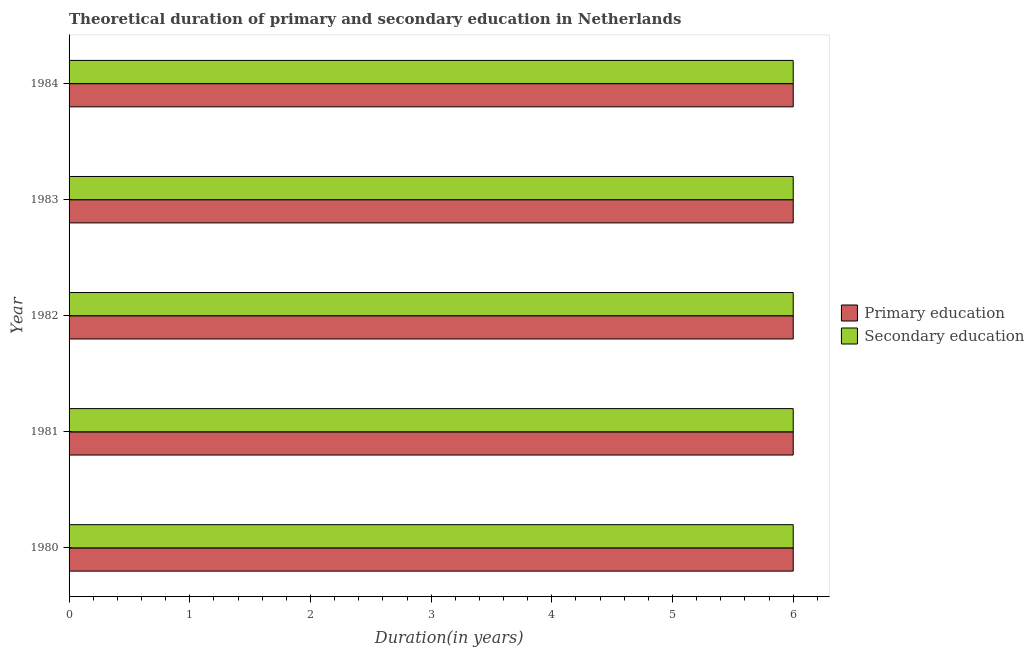Are the number of bars on each tick of the Y-axis equal?
Your answer should be compact. Yes. How many bars are there on the 2nd tick from the top?
Make the answer very short. 2. How many bars are there on the 4th tick from the bottom?
Make the answer very short. 2. What is the label of the 5th group of bars from the top?
Give a very brief answer. 1980. In how many cases, is the number of bars for a given year not equal to the number of legend labels?
Make the answer very short. 0. What is the duration of primary education in 1983?
Your answer should be very brief. 6. In which year was the duration of secondary education minimum?
Make the answer very short. 1980. What is the total duration of primary education in the graph?
Keep it short and to the point. 30. In the year 1980, what is the difference between the duration of secondary education and duration of primary education?
Ensure brevity in your answer.  0. Is the duration of primary education in 1980 less than that in 1983?
Your answer should be very brief. No. Is the difference between the duration of secondary education in 1982 and 1984 greater than the difference between the duration of primary education in 1982 and 1984?
Provide a succinct answer. No. What is the difference between the highest and the second highest duration of primary education?
Your response must be concise. 0. What is the difference between the highest and the lowest duration of secondary education?
Make the answer very short. 0. In how many years, is the duration of primary education greater than the average duration of primary education taken over all years?
Offer a terse response. 0. What does the 1st bar from the top in 1983 represents?
Make the answer very short. Secondary education. How many years are there in the graph?
Offer a very short reply. 5. What is the difference between two consecutive major ticks on the X-axis?
Ensure brevity in your answer.  1. How are the legend labels stacked?
Your answer should be very brief. Vertical. What is the title of the graph?
Your answer should be compact. Theoretical duration of primary and secondary education in Netherlands. Does "Age 15+" appear as one of the legend labels in the graph?
Your response must be concise. No. What is the label or title of the X-axis?
Keep it short and to the point. Duration(in years). What is the label or title of the Y-axis?
Offer a terse response. Year. What is the Duration(in years) in Primary education in 1981?
Keep it short and to the point. 6. What is the Duration(in years) of Secondary education in 1981?
Make the answer very short. 6. What is the Duration(in years) of Primary education in 1982?
Give a very brief answer. 6. What is the Duration(in years) in Secondary education in 1982?
Provide a short and direct response. 6. What is the Duration(in years) in Primary education in 1983?
Make the answer very short. 6. What is the Duration(in years) of Secondary education in 1983?
Make the answer very short. 6. Across all years, what is the maximum Duration(in years) of Secondary education?
Offer a terse response. 6. Across all years, what is the minimum Duration(in years) of Secondary education?
Provide a short and direct response. 6. What is the total Duration(in years) in Primary education in the graph?
Your answer should be compact. 30. What is the difference between the Duration(in years) of Secondary education in 1980 and that in 1981?
Your answer should be compact. 0. What is the difference between the Duration(in years) of Primary education in 1980 and that in 1982?
Ensure brevity in your answer.  0. What is the difference between the Duration(in years) of Secondary education in 1980 and that in 1982?
Your answer should be compact. 0. What is the difference between the Duration(in years) of Secondary education in 1980 and that in 1983?
Your answer should be very brief. 0. What is the difference between the Duration(in years) of Primary education in 1981 and that in 1982?
Make the answer very short. 0. What is the difference between the Duration(in years) of Primary education in 1981 and that in 1984?
Offer a very short reply. 0. What is the difference between the Duration(in years) of Secondary education in 1982 and that in 1983?
Ensure brevity in your answer.  0. What is the difference between the Duration(in years) in Secondary education in 1982 and that in 1984?
Ensure brevity in your answer.  0. What is the difference between the Duration(in years) in Primary education in 1980 and the Duration(in years) in Secondary education in 1982?
Ensure brevity in your answer.  0. What is the difference between the Duration(in years) in Primary education in 1980 and the Duration(in years) in Secondary education in 1983?
Give a very brief answer. 0. What is the difference between the Duration(in years) in Primary education in 1982 and the Duration(in years) in Secondary education in 1983?
Provide a short and direct response. 0. What is the difference between the Duration(in years) in Primary education in 1982 and the Duration(in years) in Secondary education in 1984?
Make the answer very short. 0. In the year 1980, what is the difference between the Duration(in years) of Primary education and Duration(in years) of Secondary education?
Make the answer very short. 0. In the year 1981, what is the difference between the Duration(in years) of Primary education and Duration(in years) of Secondary education?
Keep it short and to the point. 0. In the year 1982, what is the difference between the Duration(in years) of Primary education and Duration(in years) of Secondary education?
Keep it short and to the point. 0. In the year 1983, what is the difference between the Duration(in years) of Primary education and Duration(in years) of Secondary education?
Your response must be concise. 0. What is the ratio of the Duration(in years) in Primary education in 1980 to that in 1981?
Keep it short and to the point. 1. What is the ratio of the Duration(in years) of Secondary education in 1980 to that in 1982?
Offer a terse response. 1. What is the ratio of the Duration(in years) in Primary education in 1980 to that in 1984?
Your answer should be very brief. 1. What is the ratio of the Duration(in years) in Primary education in 1981 to that in 1982?
Provide a short and direct response. 1. What is the ratio of the Duration(in years) of Secondary education in 1981 to that in 1983?
Make the answer very short. 1. What is the ratio of the Duration(in years) of Primary education in 1981 to that in 1984?
Offer a terse response. 1. What is the ratio of the Duration(in years) of Secondary education in 1981 to that in 1984?
Your answer should be compact. 1. What is the ratio of the Duration(in years) of Primary education in 1982 to that in 1983?
Your answer should be very brief. 1. What is the ratio of the Duration(in years) in Secondary education in 1982 to that in 1983?
Give a very brief answer. 1. What is the ratio of the Duration(in years) of Primary education in 1982 to that in 1984?
Give a very brief answer. 1. What is the ratio of the Duration(in years) in Secondary education in 1982 to that in 1984?
Keep it short and to the point. 1. What is the ratio of the Duration(in years) in Secondary education in 1983 to that in 1984?
Ensure brevity in your answer.  1. What is the difference between the highest and the second highest Duration(in years) in Primary education?
Offer a very short reply. 0. What is the difference between the highest and the lowest Duration(in years) of Primary education?
Provide a short and direct response. 0. What is the difference between the highest and the lowest Duration(in years) of Secondary education?
Ensure brevity in your answer.  0. 